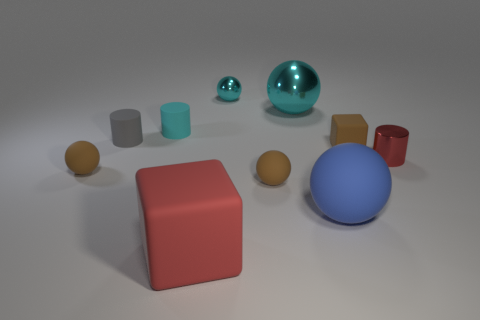What color is the big matte thing that is left of the large blue ball?
Offer a very short reply. Red. Is there a small red object that has the same shape as the gray rubber object?
Your answer should be compact. Yes. What number of blue objects are either balls or large balls?
Ensure brevity in your answer.  1. Is there a blue matte ball of the same size as the brown block?
Offer a very short reply. No. How many metallic things are there?
Provide a succinct answer. 3. What number of tiny things are either cyan matte cylinders or brown cylinders?
Offer a very short reply. 1. What is the color of the tiny cylinder that is to the right of the metallic ball on the left side of the large thing behind the small red cylinder?
Your answer should be compact. Red. How many other things are the same color as the large cube?
Give a very brief answer. 1. How many metal things are cyan balls or brown blocks?
Offer a terse response. 2. Does the cube that is behind the red cube have the same color as the small rubber thing that is on the left side of the small gray rubber thing?
Offer a very short reply. Yes. 